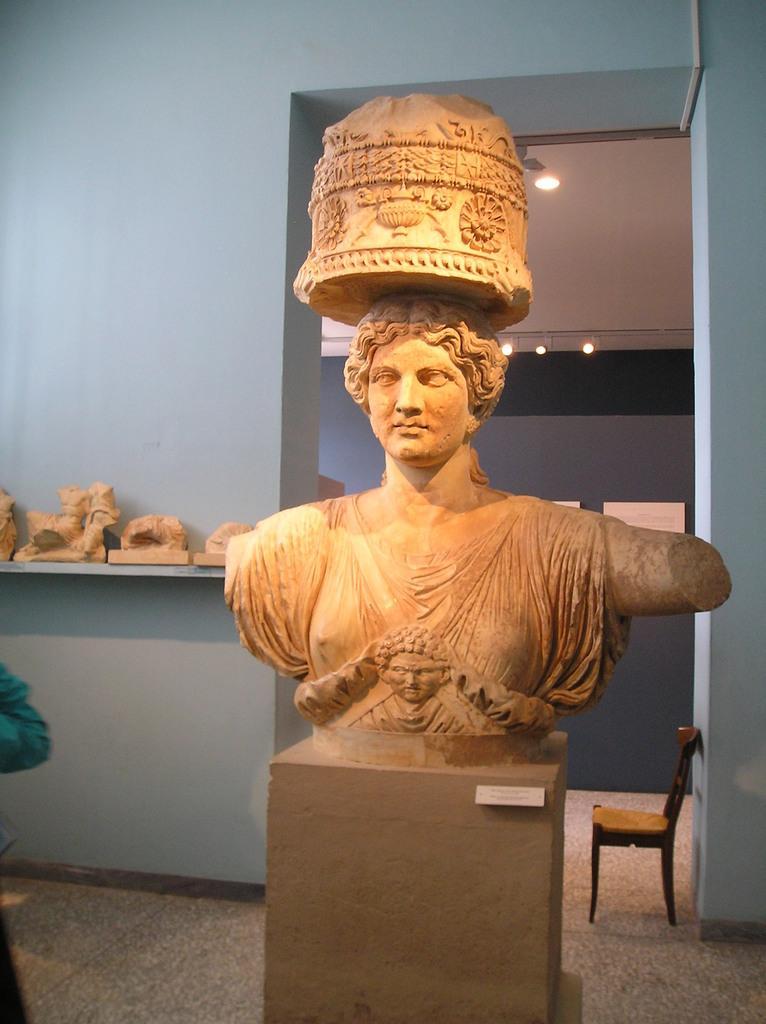Please provide a concise description of this image. This is inside of the room we can see statue. On the background we can see wall,statues on the shelf,lights,chair on the floor. 